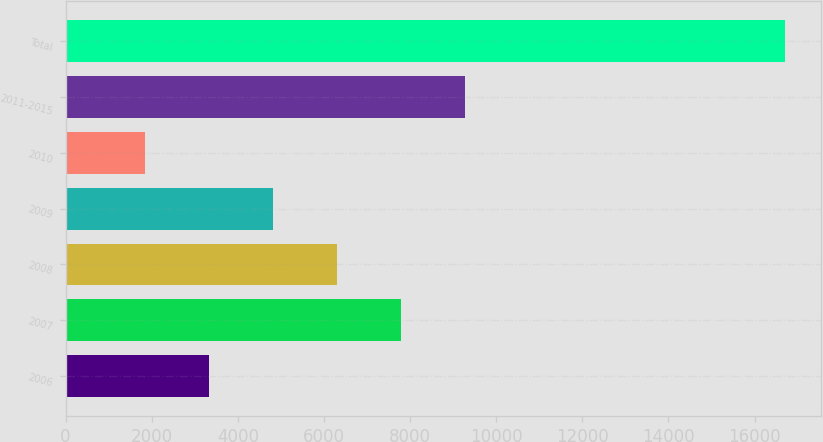<chart> <loc_0><loc_0><loc_500><loc_500><bar_chart><fcel>2006<fcel>2007<fcel>2008<fcel>2009<fcel>2010<fcel>2011-2015<fcel>Total<nl><fcel>3322.1<fcel>7783.4<fcel>6296.3<fcel>4809.2<fcel>1835<fcel>9270.5<fcel>16706<nl></chart> 